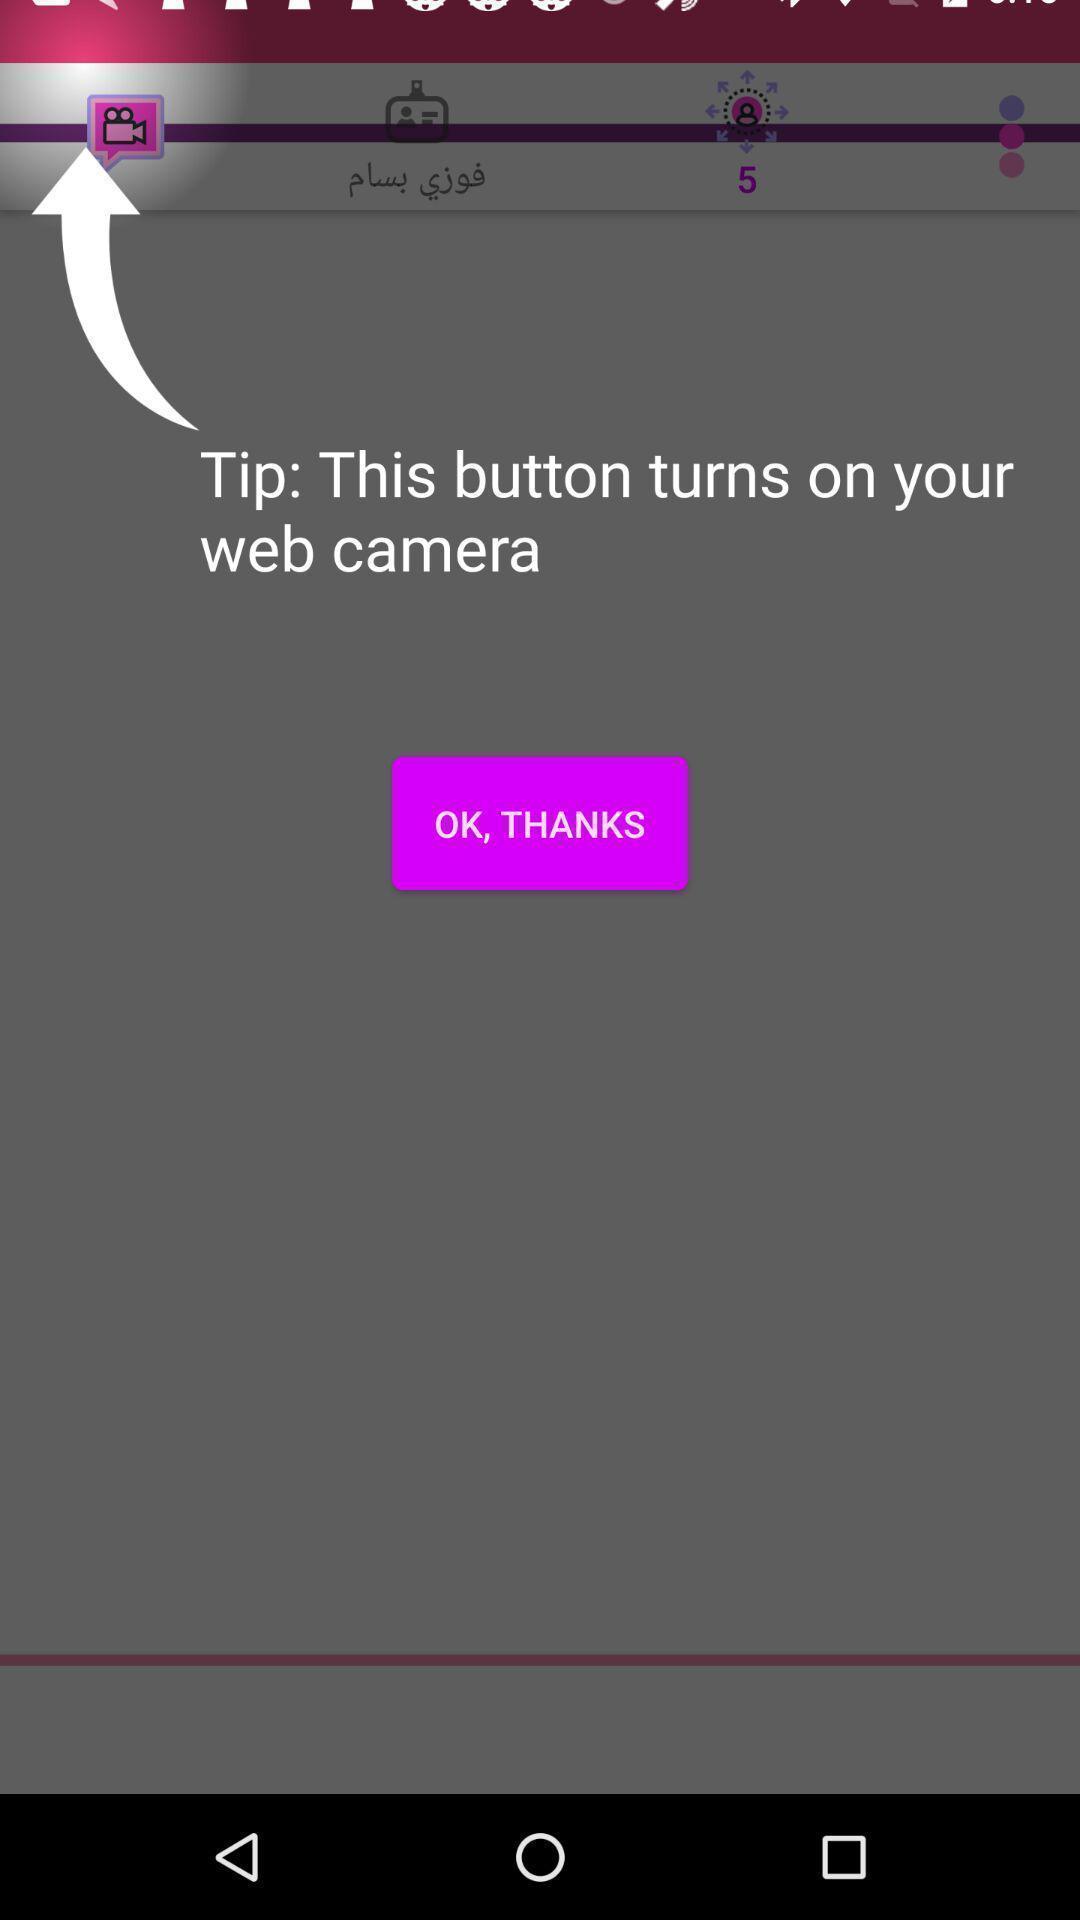Explain what's happening in this screen capture. Screen displaying demo instructions to access an application. 